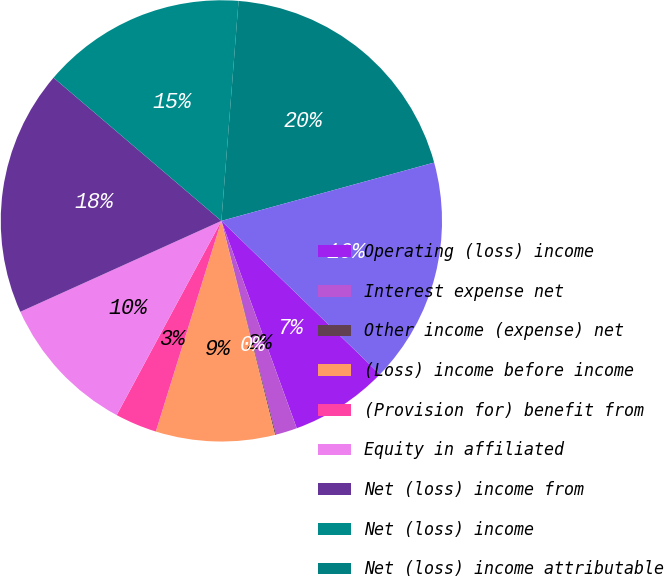Convert chart to OTSL. <chart><loc_0><loc_0><loc_500><loc_500><pie_chart><fcel>Operating (loss) income<fcel>Interest expense net<fcel>Other income (expense) net<fcel>(Loss) income before income<fcel>(Provision for) benefit from<fcel>Equity in affiliated<fcel>Net (loss) income from<fcel>Net (loss) income<fcel>Net (loss) income attributable<fcel>Total comprehensive (loss)<nl><fcel>7.21%<fcel>1.57%<fcel>0.07%<fcel>8.71%<fcel>3.07%<fcel>10.37%<fcel>18.0%<fcel>15.0%<fcel>19.5%<fcel>16.5%<nl></chart> 